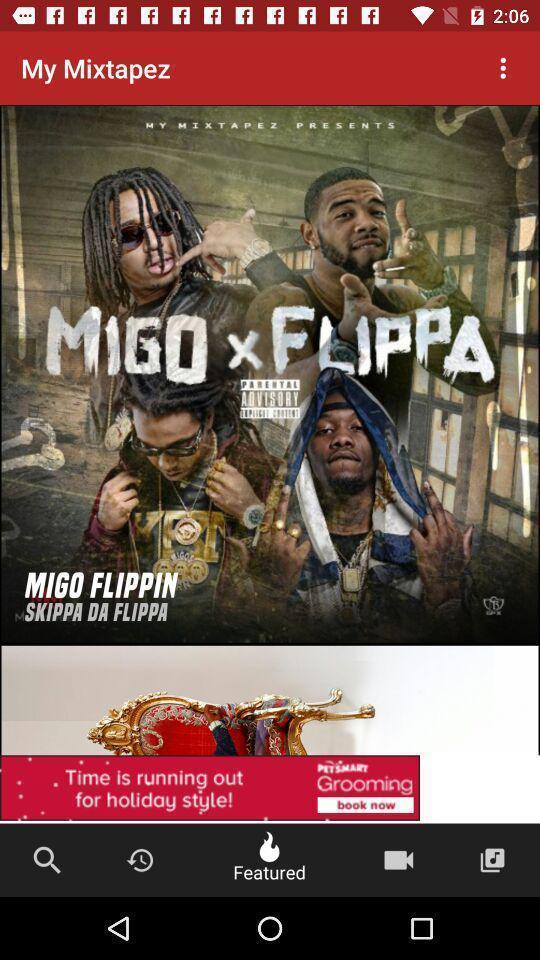Tell me what you see in this picture. Picture of a migo flippin. 